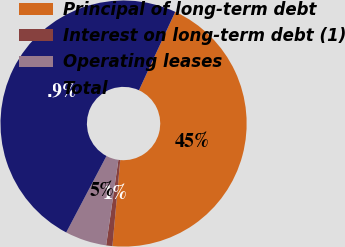Convert chart to OTSL. <chart><loc_0><loc_0><loc_500><loc_500><pie_chart><fcel>Principal of long-term debt<fcel>Interest on long-term debt (1)<fcel>Operating leases<fcel>Total<nl><fcel>44.55%<fcel>0.82%<fcel>5.45%<fcel>49.18%<nl></chart> 